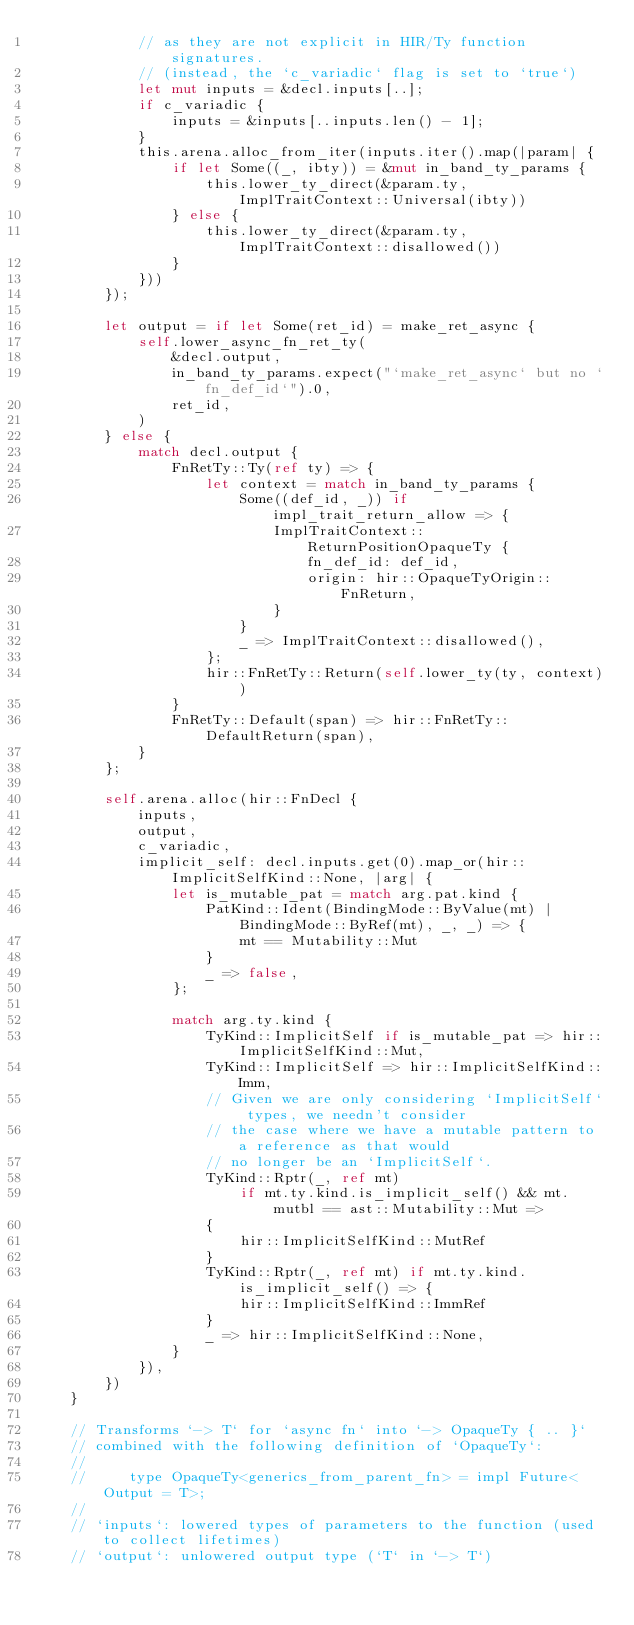Convert code to text. <code><loc_0><loc_0><loc_500><loc_500><_Rust_>            // as they are not explicit in HIR/Ty function signatures.
            // (instead, the `c_variadic` flag is set to `true`)
            let mut inputs = &decl.inputs[..];
            if c_variadic {
                inputs = &inputs[..inputs.len() - 1];
            }
            this.arena.alloc_from_iter(inputs.iter().map(|param| {
                if let Some((_, ibty)) = &mut in_band_ty_params {
                    this.lower_ty_direct(&param.ty, ImplTraitContext::Universal(ibty))
                } else {
                    this.lower_ty_direct(&param.ty, ImplTraitContext::disallowed())
                }
            }))
        });

        let output = if let Some(ret_id) = make_ret_async {
            self.lower_async_fn_ret_ty(
                &decl.output,
                in_band_ty_params.expect("`make_ret_async` but no `fn_def_id`").0,
                ret_id,
            )
        } else {
            match decl.output {
                FnRetTy::Ty(ref ty) => {
                    let context = match in_band_ty_params {
                        Some((def_id, _)) if impl_trait_return_allow => {
                            ImplTraitContext::ReturnPositionOpaqueTy {
                                fn_def_id: def_id,
                                origin: hir::OpaqueTyOrigin::FnReturn,
                            }
                        }
                        _ => ImplTraitContext::disallowed(),
                    };
                    hir::FnRetTy::Return(self.lower_ty(ty, context))
                }
                FnRetTy::Default(span) => hir::FnRetTy::DefaultReturn(span),
            }
        };

        self.arena.alloc(hir::FnDecl {
            inputs,
            output,
            c_variadic,
            implicit_self: decl.inputs.get(0).map_or(hir::ImplicitSelfKind::None, |arg| {
                let is_mutable_pat = match arg.pat.kind {
                    PatKind::Ident(BindingMode::ByValue(mt) | BindingMode::ByRef(mt), _, _) => {
                        mt == Mutability::Mut
                    }
                    _ => false,
                };

                match arg.ty.kind {
                    TyKind::ImplicitSelf if is_mutable_pat => hir::ImplicitSelfKind::Mut,
                    TyKind::ImplicitSelf => hir::ImplicitSelfKind::Imm,
                    // Given we are only considering `ImplicitSelf` types, we needn't consider
                    // the case where we have a mutable pattern to a reference as that would
                    // no longer be an `ImplicitSelf`.
                    TyKind::Rptr(_, ref mt)
                        if mt.ty.kind.is_implicit_self() && mt.mutbl == ast::Mutability::Mut =>
                    {
                        hir::ImplicitSelfKind::MutRef
                    }
                    TyKind::Rptr(_, ref mt) if mt.ty.kind.is_implicit_self() => {
                        hir::ImplicitSelfKind::ImmRef
                    }
                    _ => hir::ImplicitSelfKind::None,
                }
            }),
        })
    }

    // Transforms `-> T` for `async fn` into `-> OpaqueTy { .. }`
    // combined with the following definition of `OpaqueTy`:
    //
    //     type OpaqueTy<generics_from_parent_fn> = impl Future<Output = T>;
    //
    // `inputs`: lowered types of parameters to the function (used to collect lifetimes)
    // `output`: unlowered output type (`T` in `-> T`)</code> 